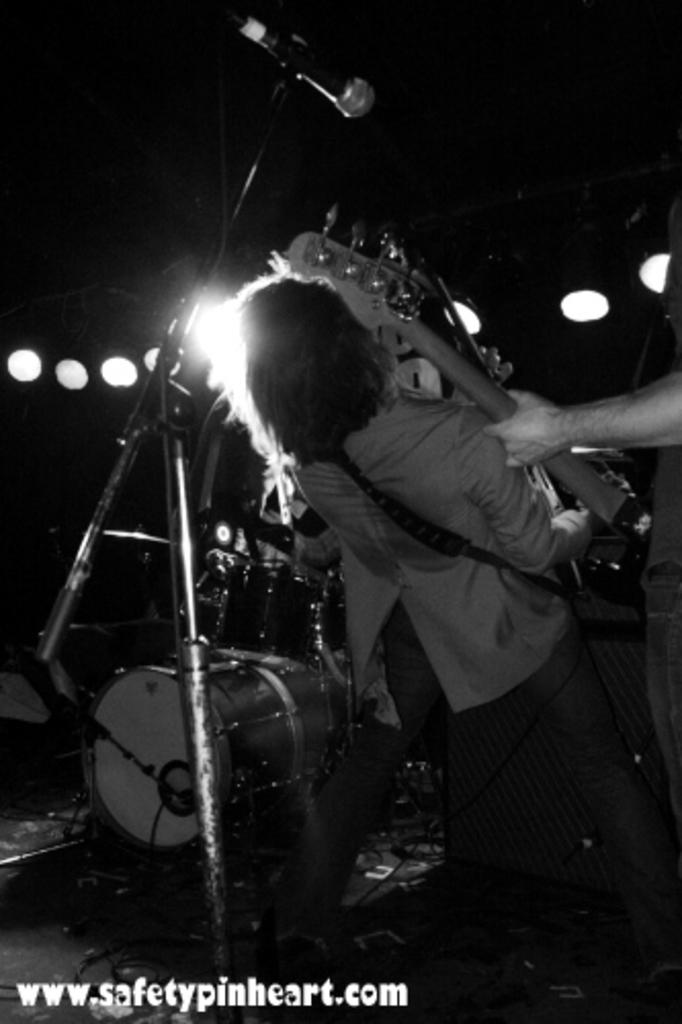What is the man in the image holding? The man is holding a guitar. What other musical instruments can be seen in the image? There are musical drums in the image. What might the man be doing in the image? The man might be playing music, given that he is holding a guitar and there are musical drums present. What type of drink is the man holding in the image? There is no drink visible in the image; the man is holding a guitar. 